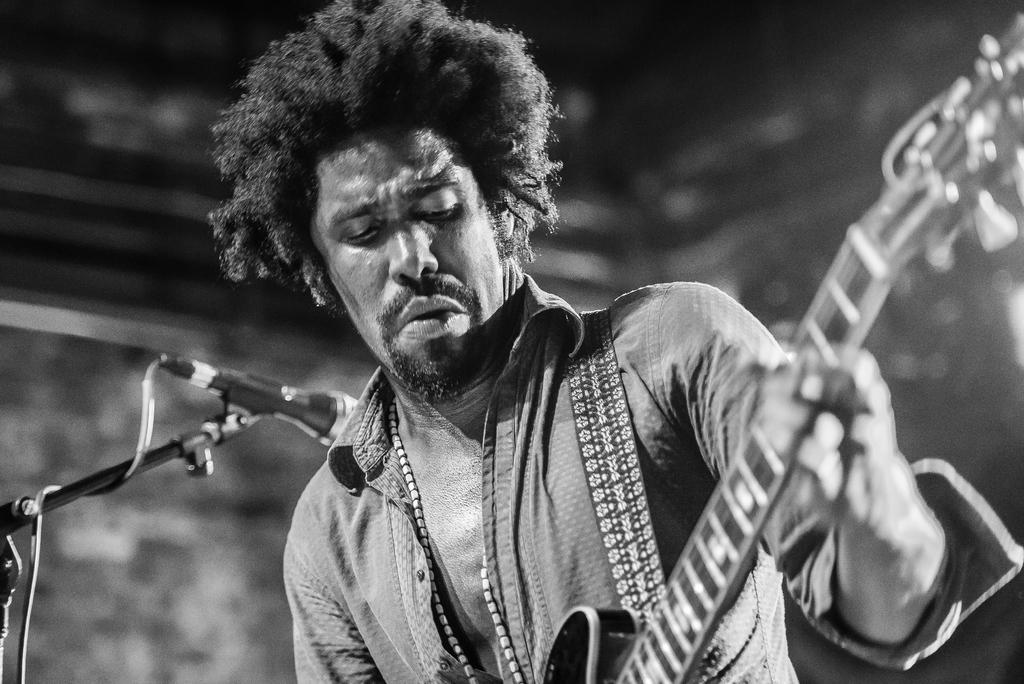What is the man in the image doing? The man is playing a guitar. What object is beside the man? There is a microphone beside the man. What type of plantation can be seen in the background of the image? There is no plantation visible in the image; it only features a man playing a guitar and a microphone beside him. 